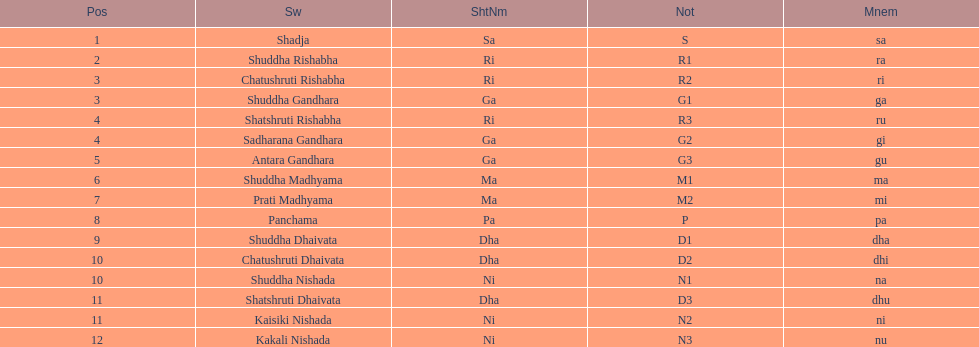What is the name of the swara that holds the first position? Shadja. Give me the full table as a dictionary. {'header': ['Pos', 'Sw', 'ShtNm', 'Not', 'Mnem'], 'rows': [['1', 'Shadja', 'Sa', 'S', 'sa'], ['2', 'Shuddha Rishabha', 'Ri', 'R1', 'ra'], ['3', 'Chatushruti Rishabha', 'Ri', 'R2', 'ri'], ['3', 'Shuddha Gandhara', 'Ga', 'G1', 'ga'], ['4', 'Shatshruti Rishabha', 'Ri', 'R3', 'ru'], ['4', 'Sadharana Gandhara', 'Ga', 'G2', 'gi'], ['5', 'Antara Gandhara', 'Ga', 'G3', 'gu'], ['6', 'Shuddha Madhyama', 'Ma', 'M1', 'ma'], ['7', 'Prati Madhyama', 'Ma', 'M2', 'mi'], ['8', 'Panchama', 'Pa', 'P', 'pa'], ['9', 'Shuddha Dhaivata', 'Dha', 'D1', 'dha'], ['10', 'Chatushruti Dhaivata', 'Dha', 'D2', 'dhi'], ['10', 'Shuddha Nishada', 'Ni', 'N1', 'na'], ['11', 'Shatshruti Dhaivata', 'Dha', 'D3', 'dhu'], ['11', 'Kaisiki Nishada', 'Ni', 'N2', 'ni'], ['12', 'Kakali Nishada', 'Ni', 'N3', 'nu']]} 